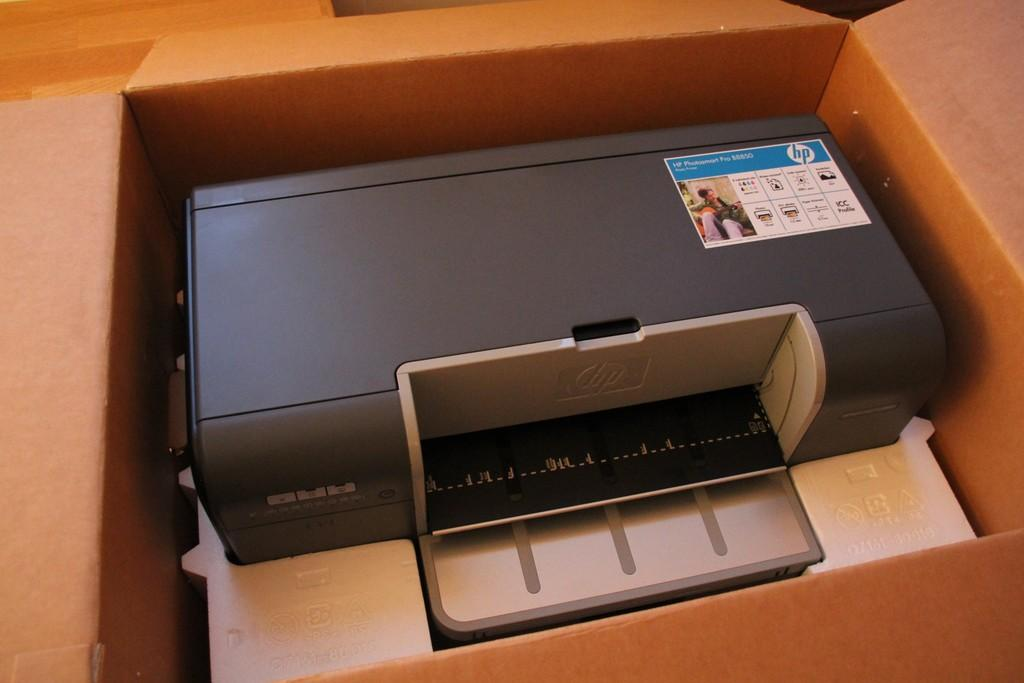What is the main object in the image? There is a printing machine in the image. How is the printing machine supported or placed? The printing machine is placed on a cotton box. What material can be seen at the bottom of the image? There is thermocol visible at the bottom of the image. How many dolls are sitting on the quartz in the image? There are no dolls or quartz present in the image. 